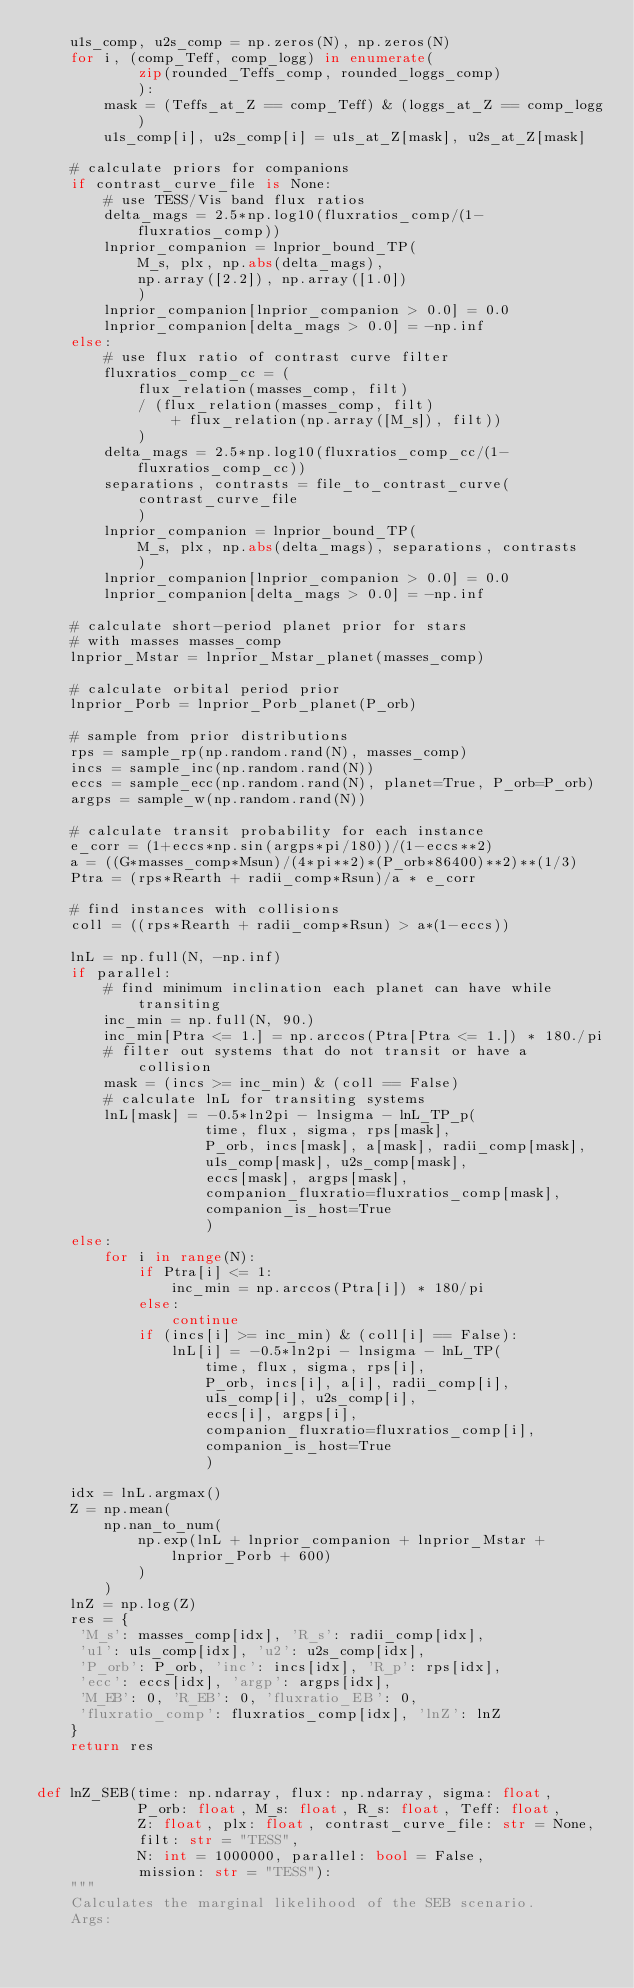Convert code to text. <code><loc_0><loc_0><loc_500><loc_500><_Python_>    u1s_comp, u2s_comp = np.zeros(N), np.zeros(N)
    for i, (comp_Teff, comp_logg) in enumerate(
            zip(rounded_Teffs_comp, rounded_loggs_comp)
            ):
        mask = (Teffs_at_Z == comp_Teff) & (loggs_at_Z == comp_logg)
        u1s_comp[i], u2s_comp[i] = u1s_at_Z[mask], u2s_at_Z[mask]

    # calculate priors for companions
    if contrast_curve_file is None:
        # use TESS/Vis band flux ratios
        delta_mags = 2.5*np.log10(fluxratios_comp/(1-fluxratios_comp))
        lnprior_companion = lnprior_bound_TP(
            M_s, plx, np.abs(delta_mags),
            np.array([2.2]), np.array([1.0])
            )
        lnprior_companion[lnprior_companion > 0.0] = 0.0
        lnprior_companion[delta_mags > 0.0] = -np.inf
    else:
        # use flux ratio of contrast curve filter
        fluxratios_comp_cc = (
            flux_relation(masses_comp, filt)
            / (flux_relation(masses_comp, filt)
                + flux_relation(np.array([M_s]), filt))
            )
        delta_mags = 2.5*np.log10(fluxratios_comp_cc/(1-fluxratios_comp_cc))
        separations, contrasts = file_to_contrast_curve(
            contrast_curve_file
            )
        lnprior_companion = lnprior_bound_TP(
            M_s, plx, np.abs(delta_mags), separations, contrasts
            )
        lnprior_companion[lnprior_companion > 0.0] = 0.0
        lnprior_companion[delta_mags > 0.0] = -np.inf

    # calculate short-period planet prior for stars
    # with masses masses_comp
    lnprior_Mstar = lnprior_Mstar_planet(masses_comp)

    # calculate orbital period prior
    lnprior_Porb = lnprior_Porb_planet(P_orb)

    # sample from prior distributions
    rps = sample_rp(np.random.rand(N), masses_comp)
    incs = sample_inc(np.random.rand(N))
    eccs = sample_ecc(np.random.rand(N), planet=True, P_orb=P_orb)
    argps = sample_w(np.random.rand(N))

    # calculate transit probability for each instance
    e_corr = (1+eccs*np.sin(argps*pi/180))/(1-eccs**2)
    a = ((G*masses_comp*Msun)/(4*pi**2)*(P_orb*86400)**2)**(1/3)
    Ptra = (rps*Rearth + radii_comp*Rsun)/a * e_corr

    # find instances with collisions
    coll = ((rps*Rearth + radii_comp*Rsun) > a*(1-eccs))

    lnL = np.full(N, -np.inf)
    if parallel:
        # find minimum inclination each planet can have while transiting
        inc_min = np.full(N, 90.)
        inc_min[Ptra <= 1.] = np.arccos(Ptra[Ptra <= 1.]) * 180./pi
        # filter out systems that do not transit or have a collision
        mask = (incs >= inc_min) & (coll == False)
        # calculate lnL for transiting systems
        lnL[mask] = -0.5*ln2pi - lnsigma - lnL_TP_p(
                    time, flux, sigma, rps[mask],
                    P_orb, incs[mask], a[mask], radii_comp[mask],
                    u1s_comp[mask], u2s_comp[mask],
                    eccs[mask], argps[mask],
                    companion_fluxratio=fluxratios_comp[mask],
                    companion_is_host=True
                    )
    else:
        for i in range(N):
            if Ptra[i] <= 1:
                inc_min = np.arccos(Ptra[i]) * 180/pi
            else:
                continue
            if (incs[i] >= inc_min) & (coll[i] == False):
                lnL[i] = -0.5*ln2pi - lnsigma - lnL_TP(
                    time, flux, sigma, rps[i],
                    P_orb, incs[i], a[i], radii_comp[i],
                    u1s_comp[i], u2s_comp[i],
                    eccs[i], argps[i],
                    companion_fluxratio=fluxratios_comp[i],
                    companion_is_host=True
                    )

    idx = lnL.argmax()
    Z = np.mean(
        np.nan_to_num(
            np.exp(lnL + lnprior_companion + lnprior_Mstar + lnprior_Porb + 600)
            )
        )
    lnZ = np.log(Z)
    res = {
     'M_s': masses_comp[idx], 'R_s': radii_comp[idx],
     'u1': u1s_comp[idx], 'u2': u2s_comp[idx],
     'P_orb': P_orb, 'inc': incs[idx], 'R_p': rps[idx],
     'ecc': eccs[idx], 'argp': argps[idx],
     'M_EB': 0, 'R_EB': 0, 'fluxratio_EB': 0,
     'fluxratio_comp': fluxratios_comp[idx], 'lnZ': lnZ
    }
    return res


def lnZ_SEB(time: np.ndarray, flux: np.ndarray, sigma: float,
            P_orb: float, M_s: float, R_s: float, Teff: float,
            Z: float, plx: float, contrast_curve_file: str = None,
            filt: str = "TESS",
            N: int = 1000000, parallel: bool = False,
            mission: str = "TESS"):
    """
    Calculates the marginal likelihood of the SEB scenario.
    Args:</code> 